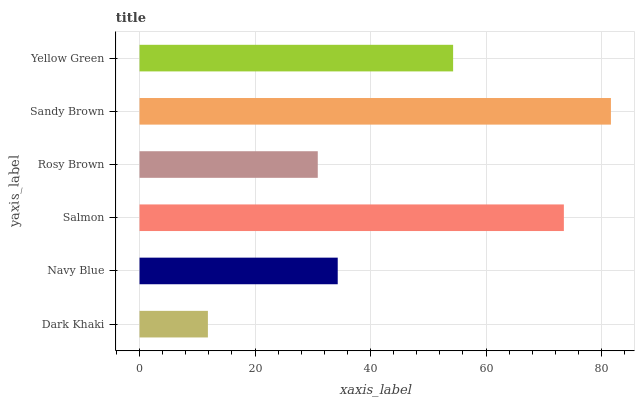Is Dark Khaki the minimum?
Answer yes or no. Yes. Is Sandy Brown the maximum?
Answer yes or no. Yes. Is Navy Blue the minimum?
Answer yes or no. No. Is Navy Blue the maximum?
Answer yes or no. No. Is Navy Blue greater than Dark Khaki?
Answer yes or no. Yes. Is Dark Khaki less than Navy Blue?
Answer yes or no. Yes. Is Dark Khaki greater than Navy Blue?
Answer yes or no. No. Is Navy Blue less than Dark Khaki?
Answer yes or no. No. Is Yellow Green the high median?
Answer yes or no. Yes. Is Navy Blue the low median?
Answer yes or no. Yes. Is Salmon the high median?
Answer yes or no. No. Is Salmon the low median?
Answer yes or no. No. 